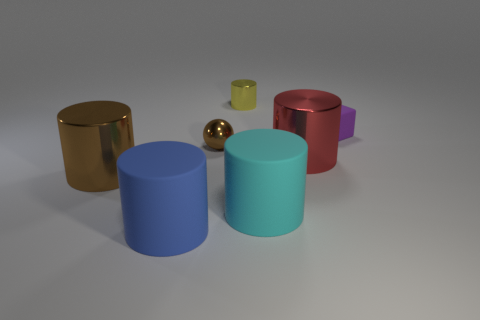There is a big brown shiny thing; is it the same shape as the thing behind the small purple cube?
Your answer should be very brief. Yes. What size is the purple matte thing?
Make the answer very short. Small. Is the number of cylinders that are to the left of the big blue cylinder less than the number of small metallic things?
Your answer should be compact. Yes. What number of rubber cubes have the same size as the sphere?
Offer a terse response. 1. What shape is the object that is the same color as the metal ball?
Your answer should be compact. Cylinder. There is a tiny ball that is to the left of the tiny purple matte thing; is its color the same as the shiny cylinder that is on the left side of the tiny yellow metallic cylinder?
Ensure brevity in your answer.  Yes. There is a tiny yellow metal cylinder; what number of blue objects are on the right side of it?
Your answer should be very brief. 0. Are there any cyan matte things of the same shape as the red metal thing?
Give a very brief answer. Yes. What color is the other metallic cylinder that is the same size as the brown metallic cylinder?
Your answer should be very brief. Red. Are there fewer big brown things right of the large blue matte cylinder than tiny brown metal objects that are left of the large red cylinder?
Your answer should be compact. Yes. 